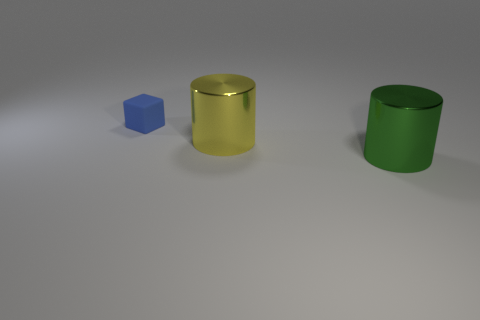Add 3 matte balls. How many objects exist? 6 Subtract all cubes. How many objects are left? 2 Subtract all tiny rubber things. Subtract all large yellow shiny things. How many objects are left? 1 Add 2 green things. How many green things are left? 3 Add 3 blue matte blocks. How many blue matte blocks exist? 4 Subtract 0 purple spheres. How many objects are left? 3 